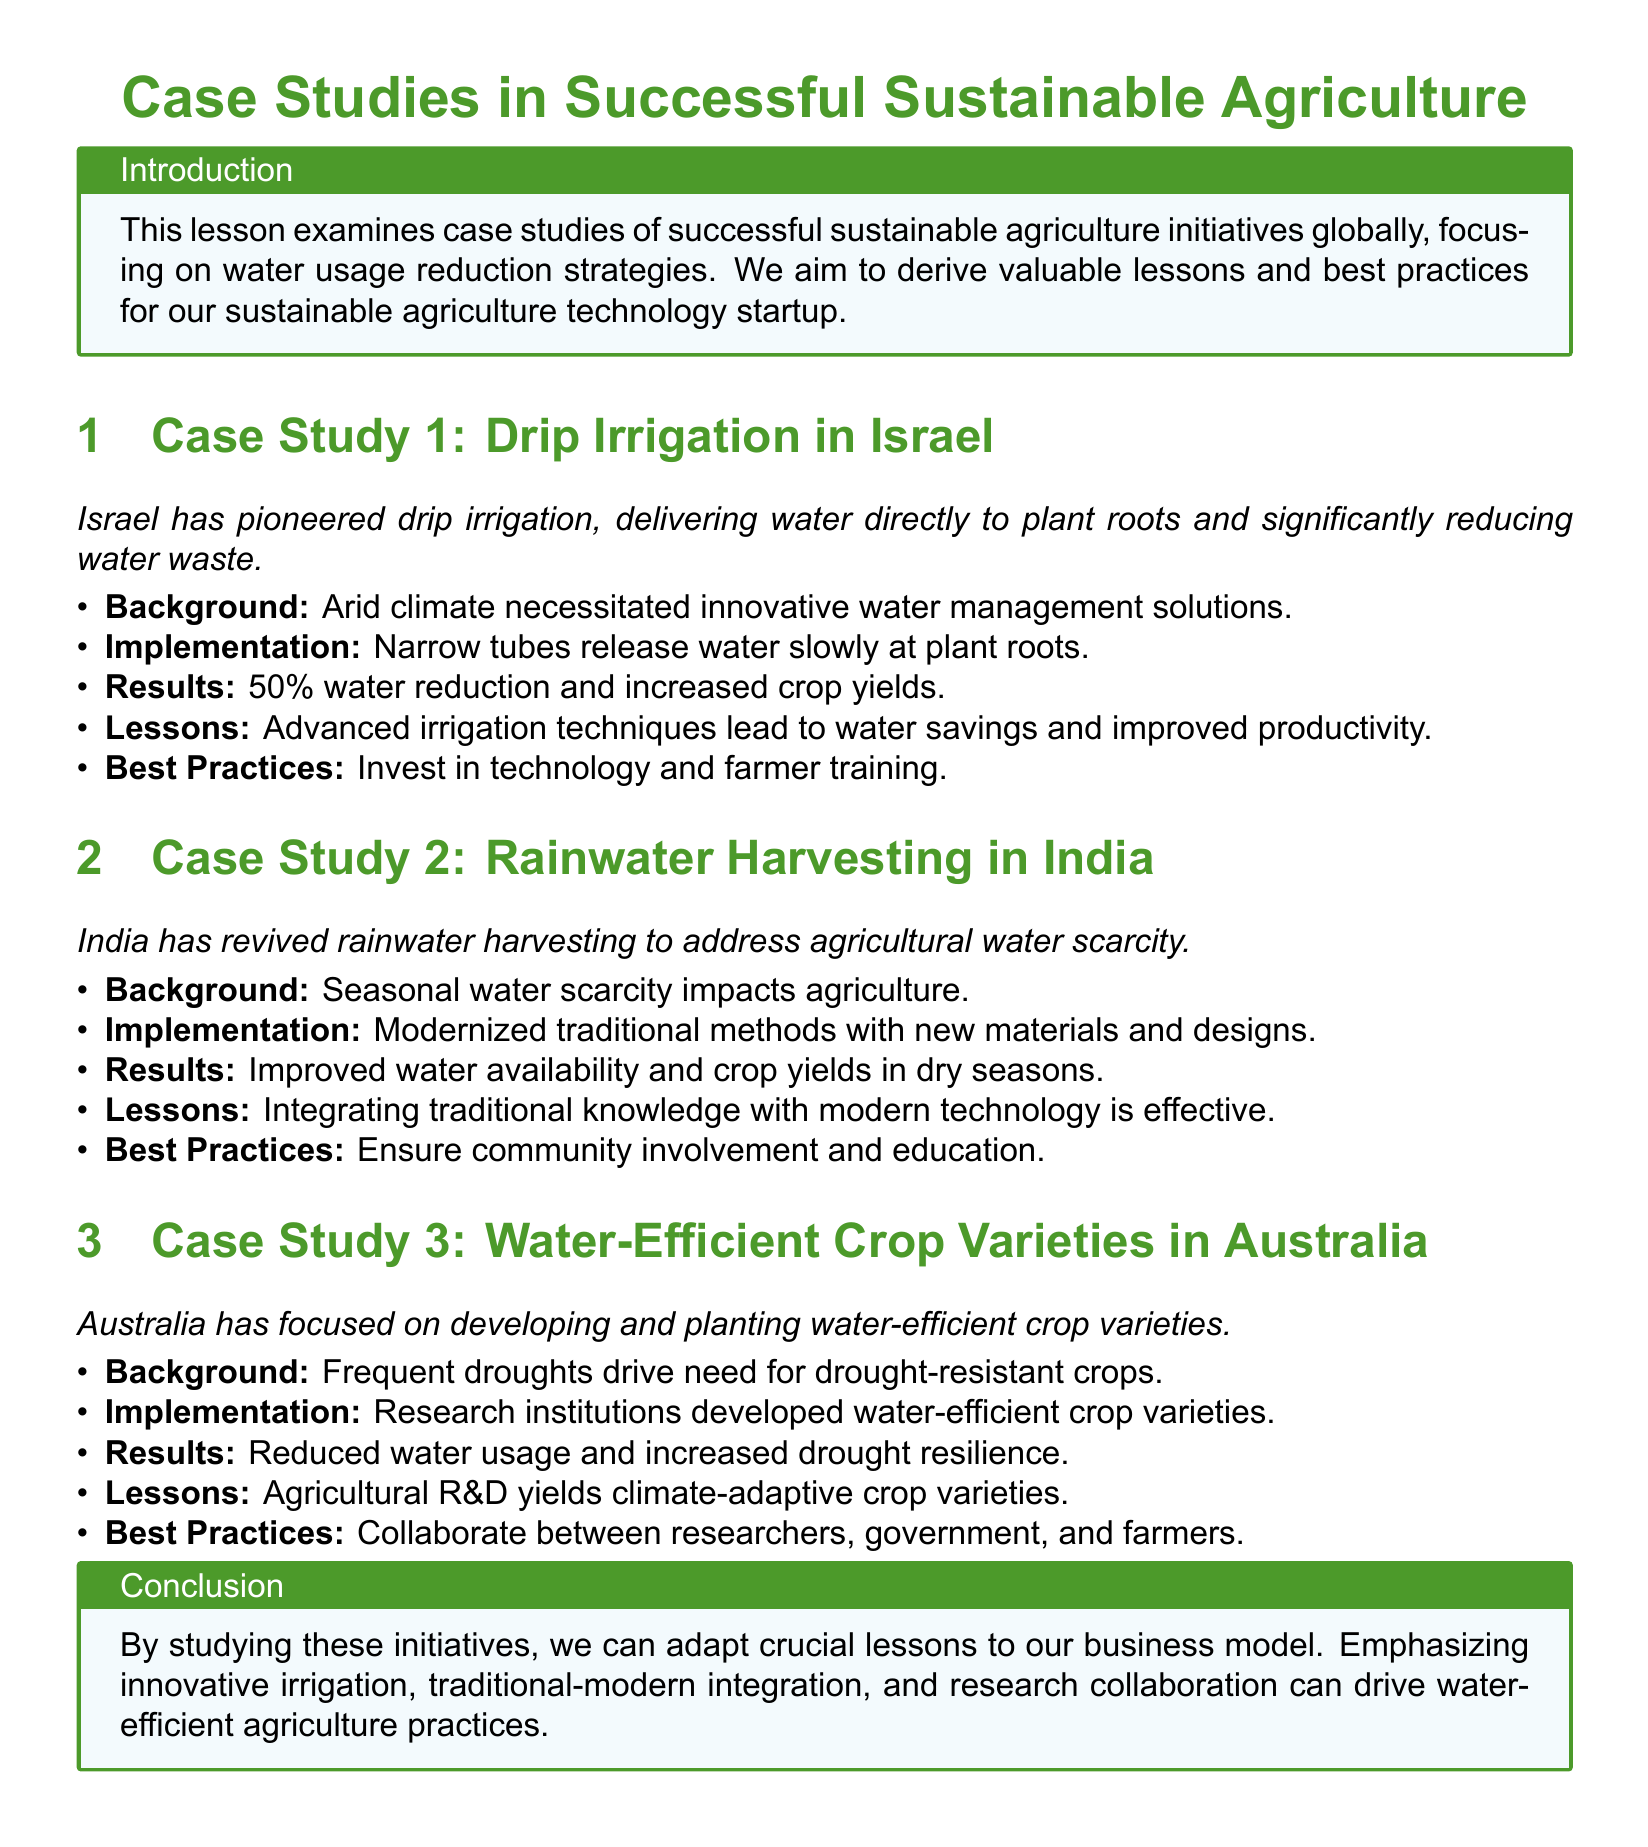What is the main focus of the lesson? The lesson examines case studies of successful sustainable agriculture initiatives globally, focusing on water usage reduction strategies.
Answer: Water usage reduction strategies How much water reduction was achieved by Drip Irrigation in Israel? The results indicated a 50% water reduction in the implementation of Drip Irrigation in Israel.
Answer: 50% What modernized method was revived in India to address water scarcity? India modernized traditional methods of rainwater harvesting to improve agricultural water availability.
Answer: Rainwater harvesting What type of crop varieties has Australia developed? Australia focused on developing water-efficient crop varieties to address the challenges of frequent droughts.
Answer: Water-efficient crop varieties What is a key lesson learned from all case studies? All case studies illustrate the importance of collaboration among various stakeholders such as researchers, government, and farmers.
Answer: Collaboration What is one best practice recommended in the case studies? One best practice emphasized is to ensure community involvement and education in water management strategies.
Answer: Community involvement and education What type of climate did Israel address with their irrigation techniques? Israel's irrigation techniques were implemented to address the challenges posed by an arid climate.
Answer: Arid climate Which country focuses on integrating traditional and modern knowledge in agriculture? The case study from India highlights the effective integration of traditional knowledge with modern technology in agriculture.
Answer: India What impact did the initiatives have on crop yields? The initiatives discussed resulted in increased crop yields as farmers utilized water more efficiently.
Answer: Increased crop yields 